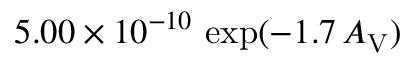Convert formula to latex. <formula><loc_0><loc_0><loc_500><loc_500>5 . 0 0 \times 1 0 ^ { - 1 0 } \, \exp ( - 1 . 7 \, A _ { V } )</formula> 